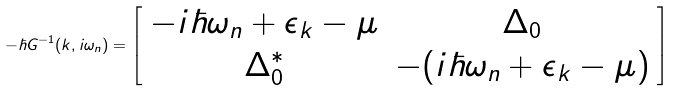<formula> <loc_0><loc_0><loc_500><loc_500>- \hbar { G } ^ { - 1 } ( { k } , i \omega _ { n } ) = \left [ \begin{array} { c c } - i \hbar { \omega } _ { n } + \epsilon _ { k } - \mu & \Delta _ { 0 } \\ \Delta ^ { * } _ { 0 } & - ( i \hbar { \omega } _ { n } + \epsilon _ { k } - \mu ) \end{array} \right ]</formula> 